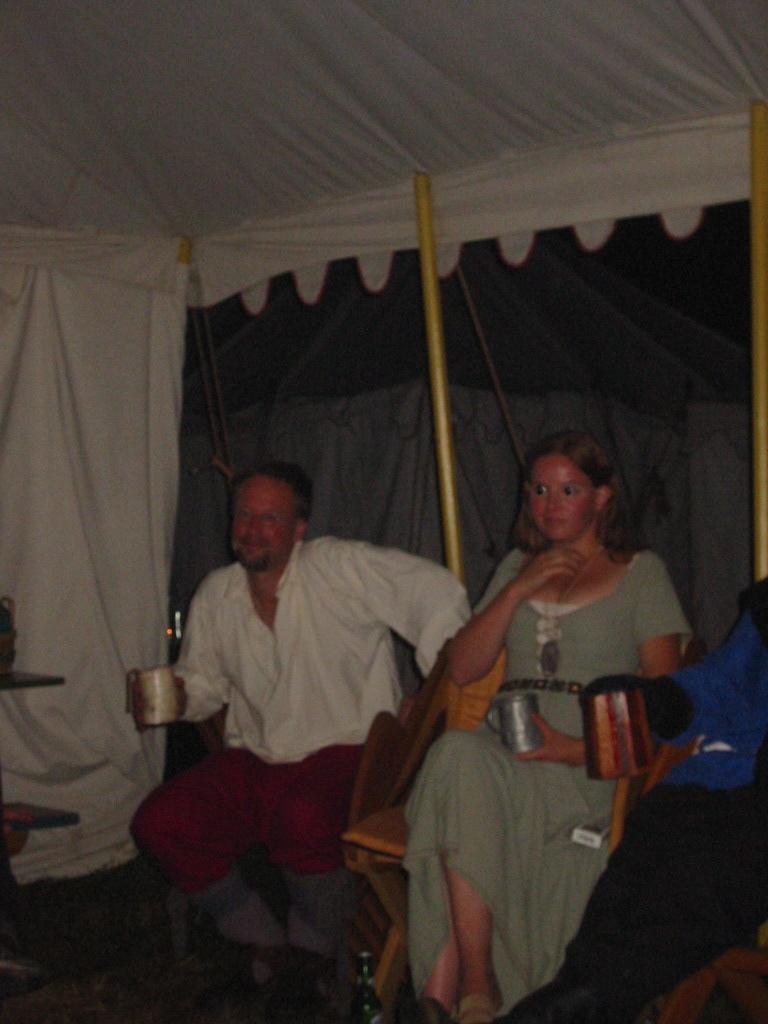Could you give a brief overview of what you see in this image? In this image we can see one white tent with poles, two wires, one bottle on the ground, one object on the table on the left side of the image, two objects on the ground on the bottom left side of the image, three people sitting on the chairs and holding objects. One object looks like a tent in the background and the background is blurred. 